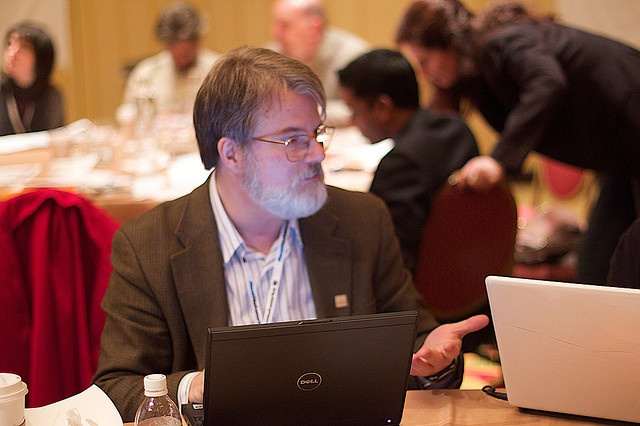Describe the objects in this image and their specific colors. I can see people in tan, maroon, black, and darkgray tones, people in tan, black, maroon, and brown tones, laptop in tan, black, maroon, and gray tones, chair in tan, maroon, and brown tones, and laptop in tan and salmon tones in this image. 